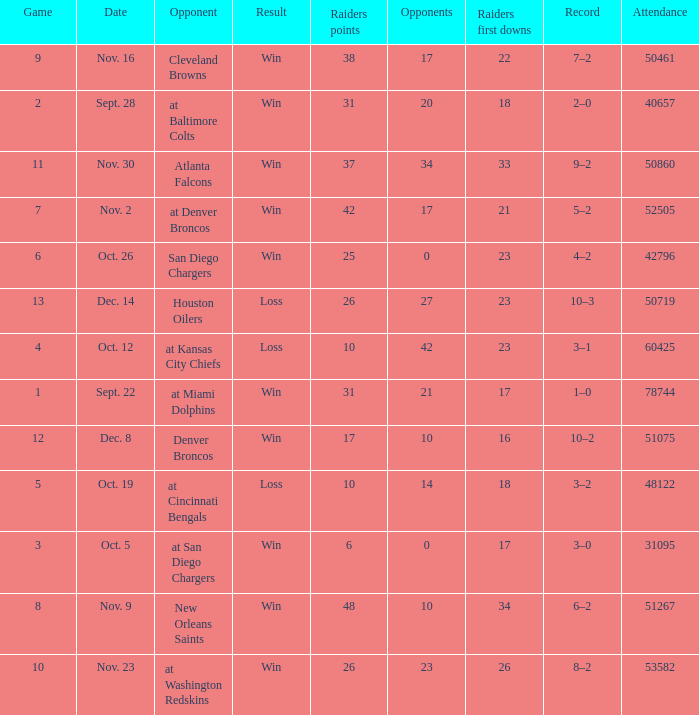Who was the game attended by 60425 people played against? At kansas city chiefs. 